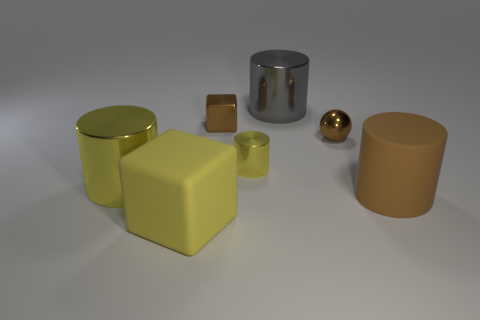What is the shape of the big rubber object that is the same color as the tiny metal block?
Offer a very short reply. Cylinder. Are there any large metallic objects of the same color as the tiny metal cylinder?
Make the answer very short. Yes. What size is the metal thing that is the same color as the tiny sphere?
Your response must be concise. Small. What shape is the big object that is to the right of the large yellow block and to the left of the small sphere?
Make the answer very short. Cylinder. What number of objects are big gray metal cylinders or large cylinders?
Make the answer very short. 3. There is a rubber object that is on the left side of the large brown thing; what is its size?
Keep it short and to the point. Large. The metallic object that is both on the left side of the tiny shiny cylinder and in front of the small brown ball is what color?
Your answer should be very brief. Yellow. Is the material of the large yellow object that is behind the big brown cylinder the same as the brown cylinder?
Provide a succinct answer. No. Is the color of the ball the same as the rubber thing behind the rubber cube?
Your answer should be compact. Yes. There is a gray shiny cylinder; are there any small metallic spheres in front of it?
Keep it short and to the point. Yes. 